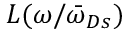Convert formula to latex. <formula><loc_0><loc_0><loc_500><loc_500>L ( \omega / { \bar { \omega } } _ { D s } )</formula> 